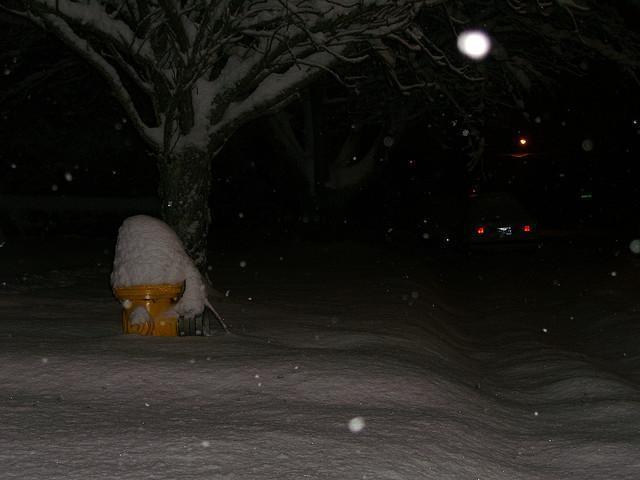How many buckets are visible?
Give a very brief answer. 1. 